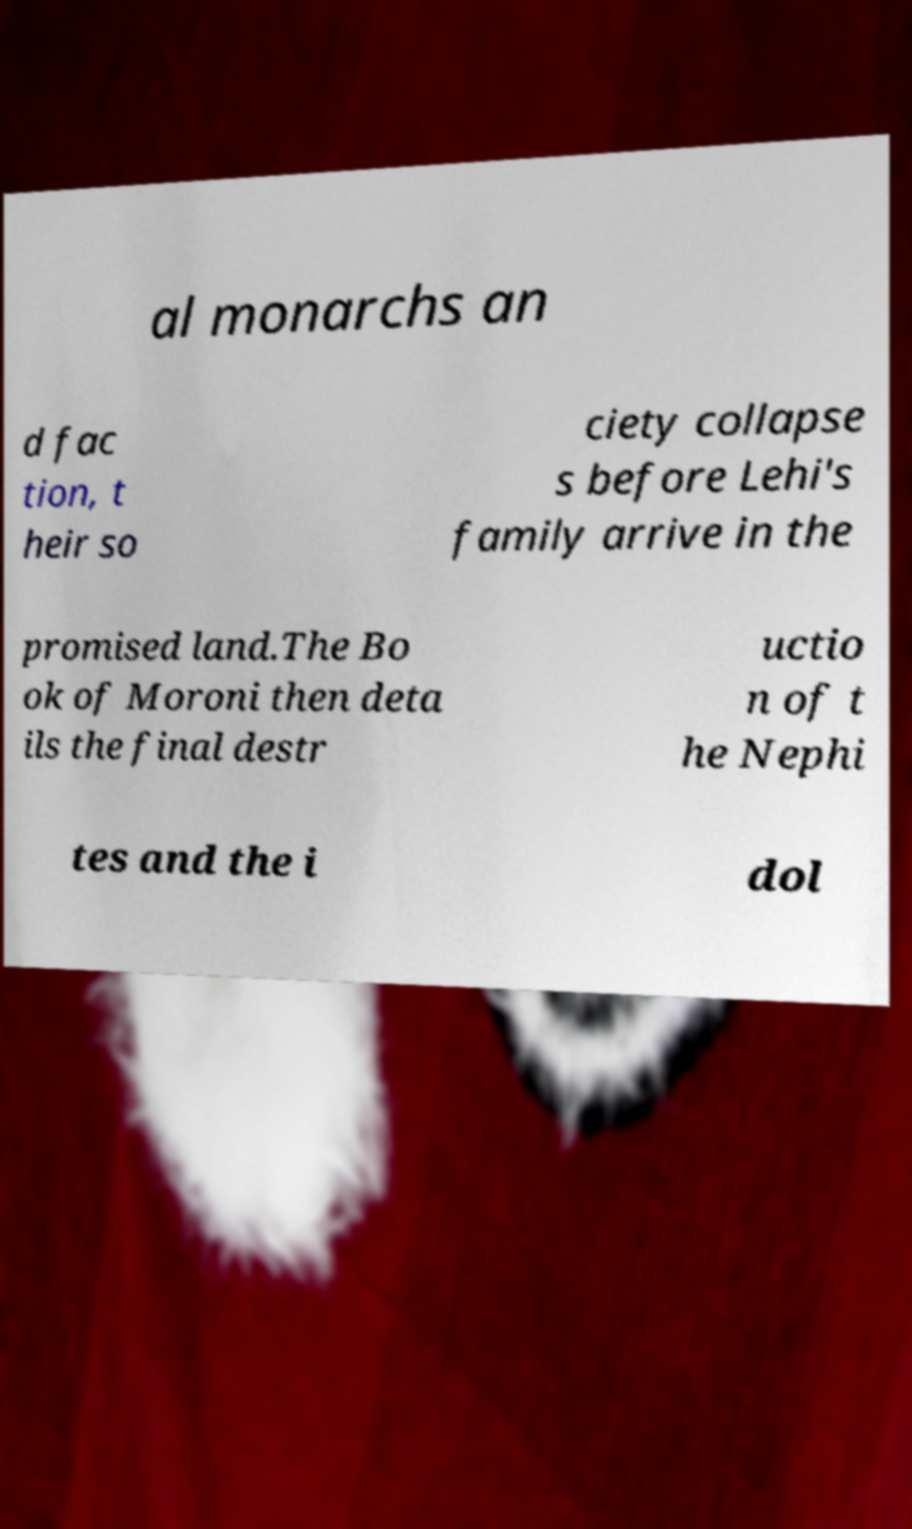Please identify and transcribe the text found in this image. al monarchs an d fac tion, t heir so ciety collapse s before Lehi's family arrive in the promised land.The Bo ok of Moroni then deta ils the final destr uctio n of t he Nephi tes and the i dol 